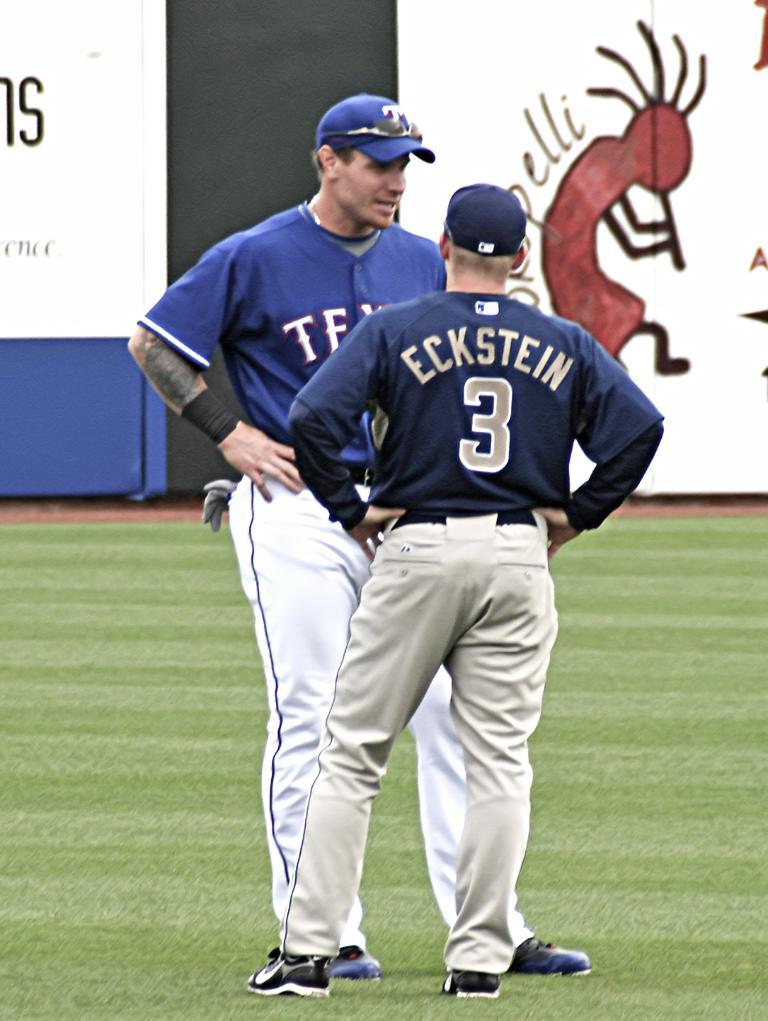<image>
Describe the image concisely. 2 Texas Rangers players talking on the field, one of the jerseys says Eckstein #3. 